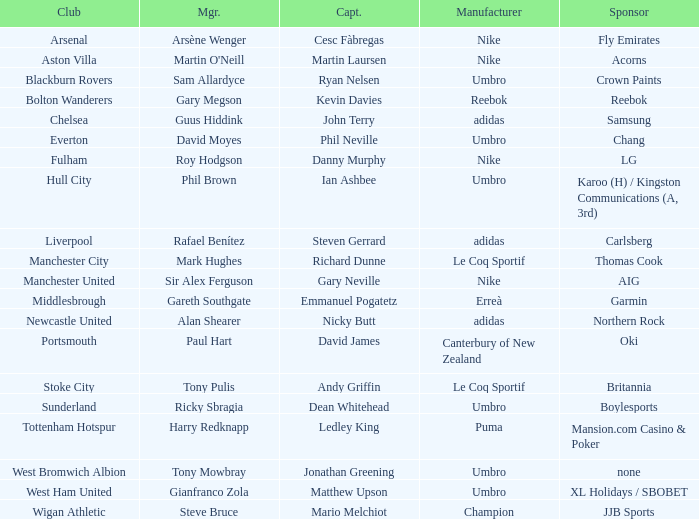Which Manchester United captain is sponsored by Nike? Gary Neville. 